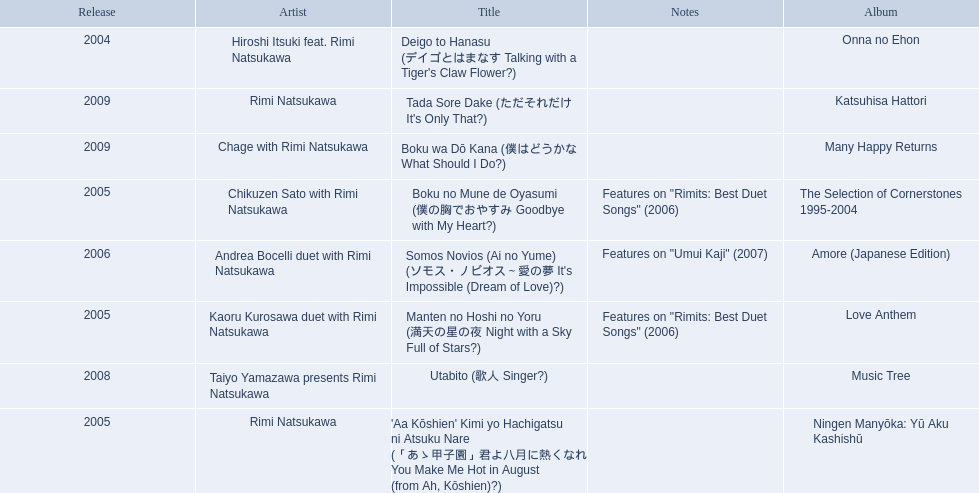What are the names of each album by rimi natsukawa? Onna no Ehon, The Selection of Cornerstones 1995-2004, Ningen Manyōka: Yū Aku Kashishū, Love Anthem, Amore (Japanese Edition), Music Tree, Many Happy Returns, Katsuhisa Hattori. And when were the albums released? 2004, 2005, 2005, 2005, 2006, 2008, 2009, 2009. Was onna no ehon or music tree released most recently? Music Tree. 